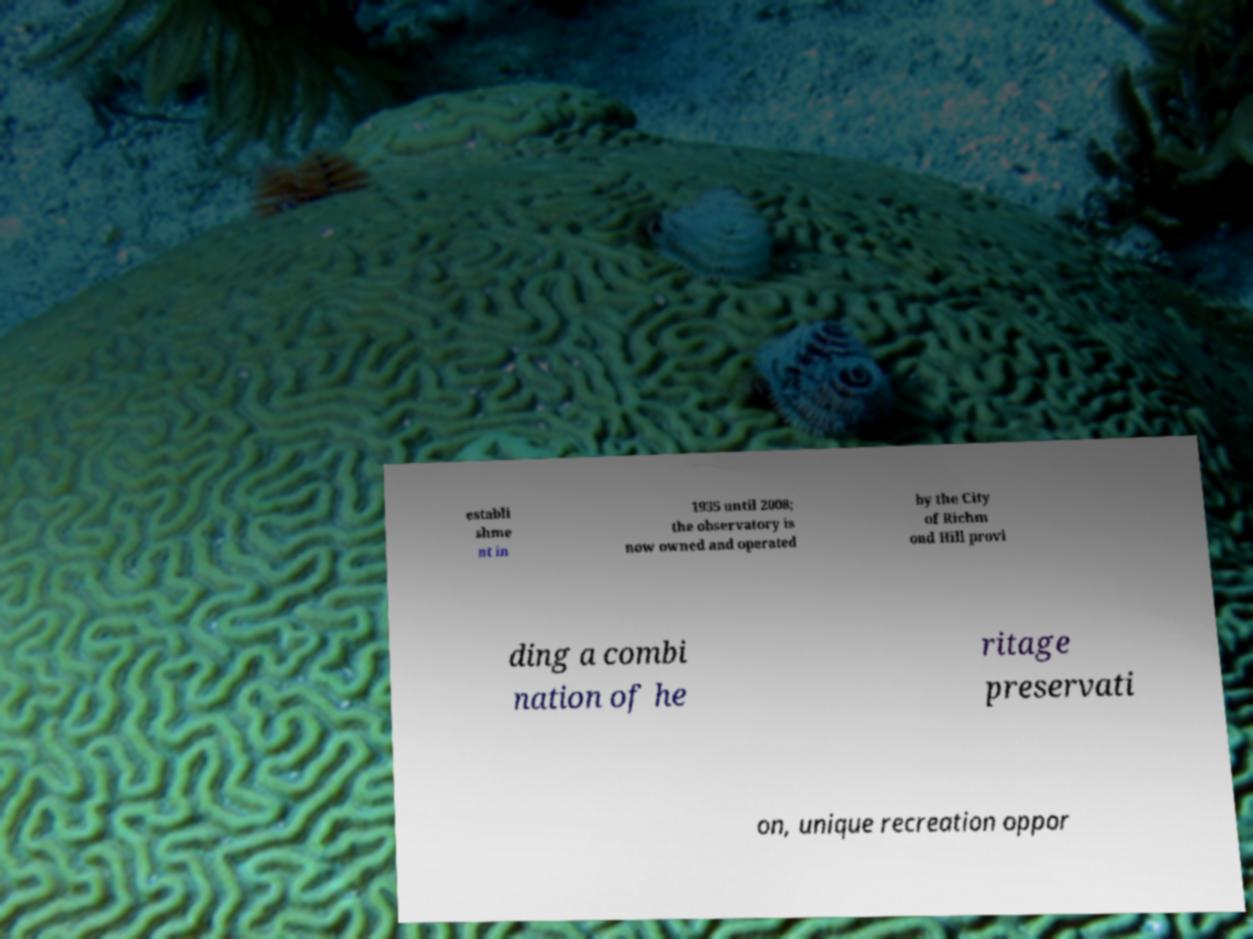Please identify and transcribe the text found in this image. establi shme nt in 1935 until 2008; the observatory is now owned and operated by the City of Richm ond Hill provi ding a combi nation of he ritage preservati on, unique recreation oppor 